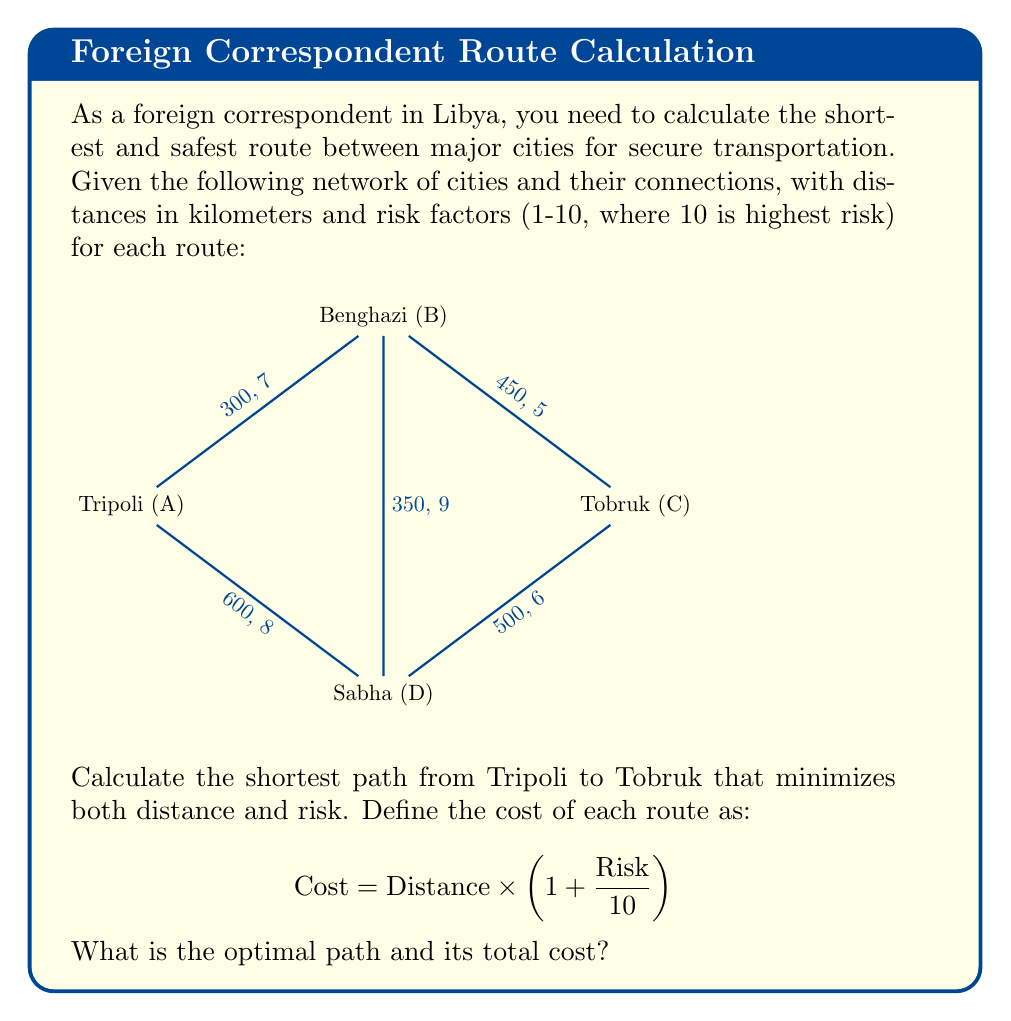Could you help me with this problem? To solve this problem, we'll use Dijkstra's algorithm with the modified cost function. Let's calculate the cost for each route:

1. Tripoli (A) to Benghazi (B): $300 \times (1 + \frac{7}{10}) = 510$
2. Benghazi (B) to Tobruk (C): $450 \times (1 + \frac{5}{10}) = 675$
3. Tripoli (A) to Sabha (D): $600 \times (1 + \frac{8}{10}) = 1080$
4. Sabha (D) to Tobruk (C): $500 \times (1 + \frac{6}{10}) = 800$
5. Benghazi (B) to Sabha (D): $350 \times (1 + \frac{9}{10}) = 665$

Now, let's apply Dijkstra's algorithm:

1. Start at Tripoli (A)
2. Cost to Benghazi (B): 510
3. Cost to Sabha (D): 1080
4. Choose Benghazi (B) as it has the lower cost
5. From Benghazi (B):
   - Cost to Tobruk (C): 510 + 675 = 1185
   - Cost to Sabha (D): 510 + 665 = 1175
6. Choose Sabha (D) as it has the lower cost
7. From Sabha (D):
   - Cost to Tobruk (C): 1175 + 800 = 1975

The shortest path is Tripoli (A) -> Benghazi (B) -> Tobruk (C) with a total cost of 1185.
Answer: Tripoli -> Benghazi -> Tobruk; Total cost: 1185 